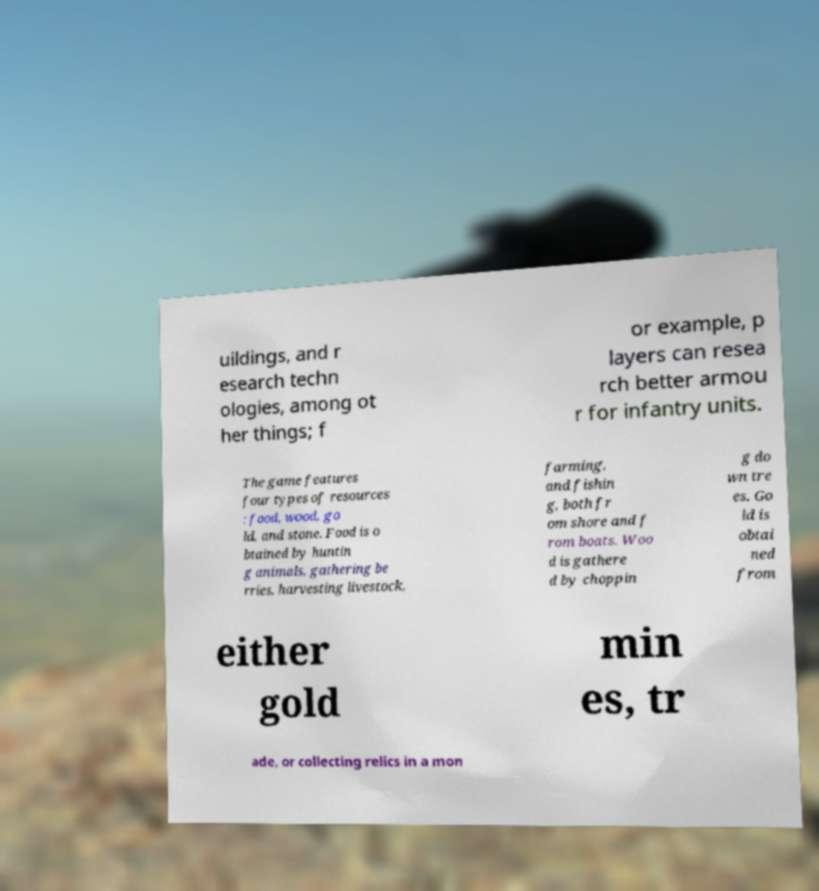Can you read and provide the text displayed in the image?This photo seems to have some interesting text. Can you extract and type it out for me? uildings, and r esearch techn ologies, among ot her things; f or example, p layers can resea rch better armou r for infantry units. The game features four types of resources : food, wood, go ld, and stone. Food is o btained by huntin g animals, gathering be rries, harvesting livestock, farming, and fishin g, both fr om shore and f rom boats. Woo d is gathere d by choppin g do wn tre es. Go ld is obtai ned from either gold min es, tr ade, or collecting relics in a mon 